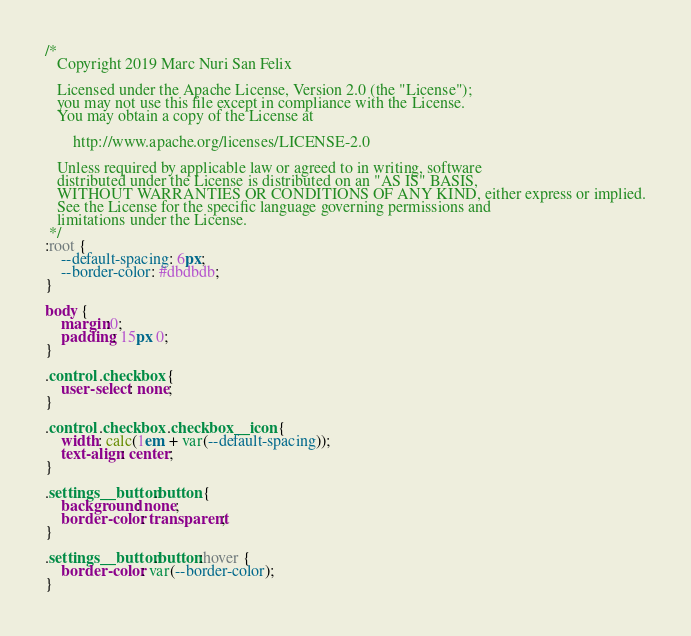Convert code to text. <code><loc_0><loc_0><loc_500><loc_500><_CSS_>/*
   Copyright 2019 Marc Nuri San Felix

   Licensed under the Apache License, Version 2.0 (the "License");
   you may not use this file except in compliance with the License.
   You may obtain a copy of the License at

       http://www.apache.org/licenses/LICENSE-2.0

   Unless required by applicable law or agreed to in writing, software
   distributed under the License is distributed on an "AS IS" BASIS,
   WITHOUT WARRANTIES OR CONDITIONS OF ANY KIND, either express or implied.
   See the License for the specific language governing permissions and
   limitations under the License.
 */
:root {
    --default-spacing: 6px;
    --border-color: #dbdbdb;
}

body {
    margin:0;
    padding: 15px 0;
}

.control .checkbox {
    user-select: none;
}

.control .checkbox .checkbox__icon {
    width: calc(1em + var(--default-spacing));
    text-align: center;
}

.settings__button.button {
    background: none;
    border-color: transparent;
}

.settings__button.button:hover {
    border-color: var(--border-color);
}
</code> 